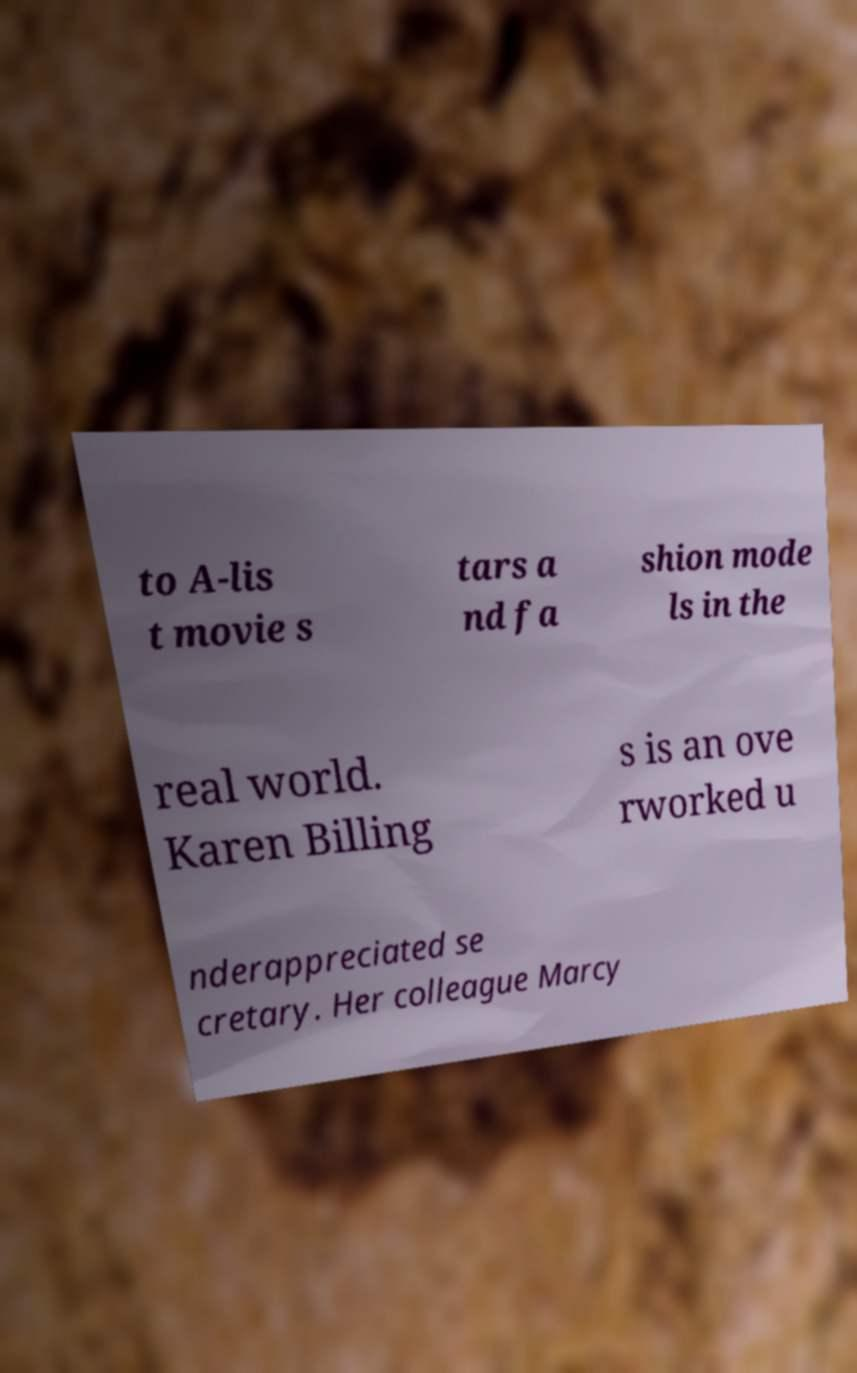There's text embedded in this image that I need extracted. Can you transcribe it verbatim? to A-lis t movie s tars a nd fa shion mode ls in the real world. Karen Billing s is an ove rworked u nderappreciated se cretary. Her colleague Marcy 